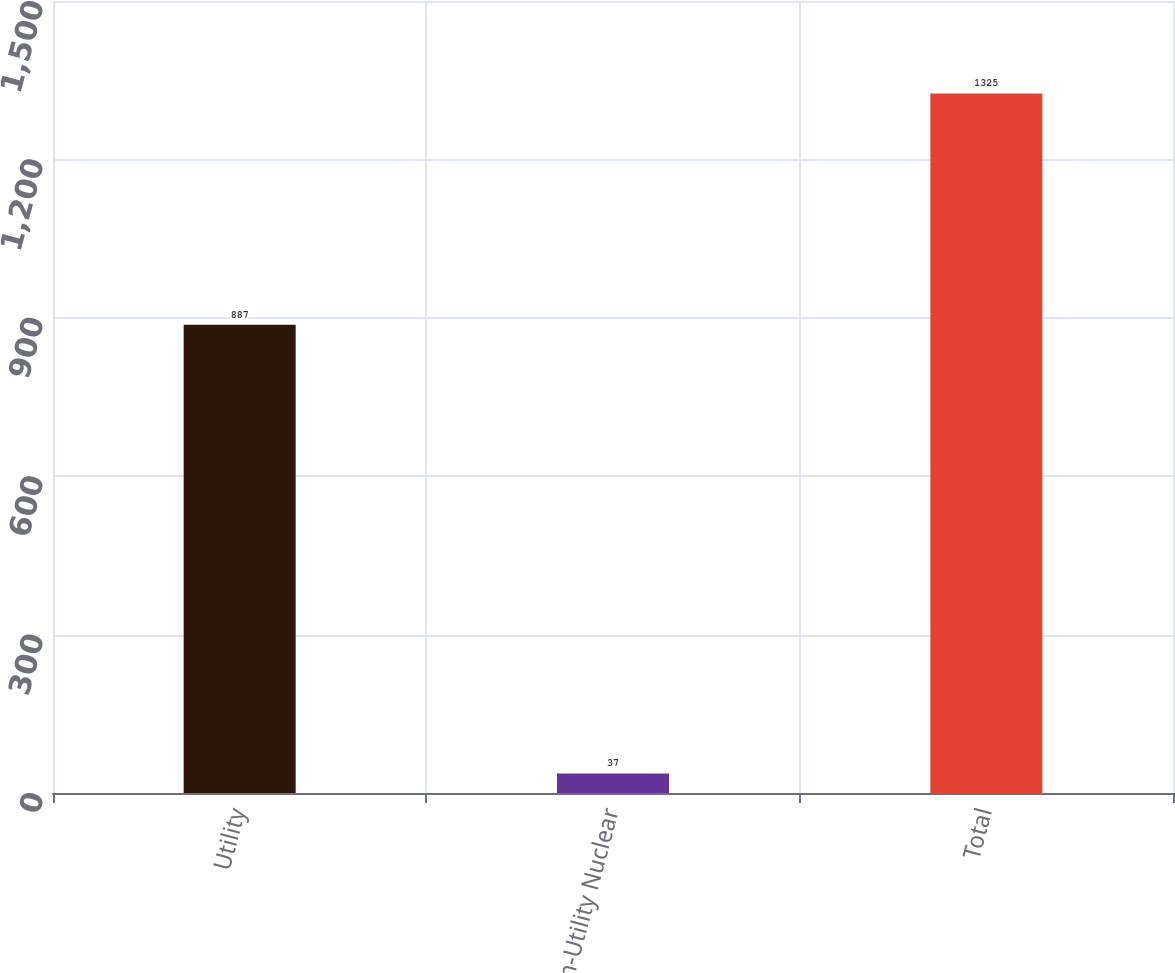<chart> <loc_0><loc_0><loc_500><loc_500><bar_chart><fcel>Utility<fcel>Non-Utility Nuclear<fcel>Total<nl><fcel>887<fcel>37<fcel>1325<nl></chart> 